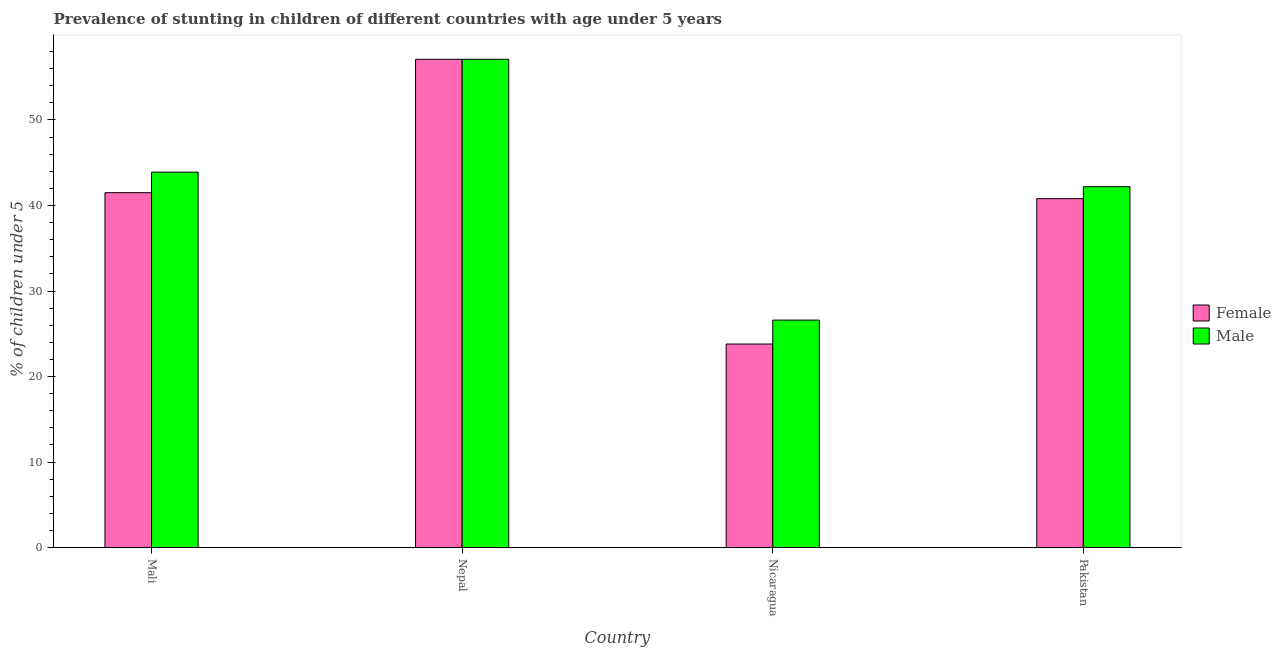Are the number of bars on each tick of the X-axis equal?
Your response must be concise. Yes. How many bars are there on the 1st tick from the left?
Offer a terse response. 2. How many bars are there on the 2nd tick from the right?
Your answer should be compact. 2. What is the label of the 4th group of bars from the left?
Keep it short and to the point. Pakistan. In how many cases, is the number of bars for a given country not equal to the number of legend labels?
Offer a terse response. 0. What is the percentage of stunted female children in Nepal?
Keep it short and to the point. 57.1. Across all countries, what is the maximum percentage of stunted female children?
Offer a terse response. 57.1. Across all countries, what is the minimum percentage of stunted female children?
Your response must be concise. 23.8. In which country was the percentage of stunted female children maximum?
Keep it short and to the point. Nepal. In which country was the percentage of stunted female children minimum?
Offer a very short reply. Nicaragua. What is the total percentage of stunted male children in the graph?
Make the answer very short. 169.8. What is the difference between the percentage of stunted male children in Mali and that in Nepal?
Keep it short and to the point. -13.2. What is the difference between the percentage of stunted female children in Mali and the percentage of stunted male children in Nepal?
Your answer should be very brief. -15.6. What is the average percentage of stunted female children per country?
Keep it short and to the point. 40.8. What is the difference between the percentage of stunted female children and percentage of stunted male children in Pakistan?
Provide a succinct answer. -1.4. In how many countries, is the percentage of stunted female children greater than 8 %?
Offer a terse response. 4. What is the ratio of the percentage of stunted male children in Nepal to that in Nicaragua?
Provide a succinct answer. 2.15. Is the percentage of stunted female children in Nepal less than that in Pakistan?
Your answer should be very brief. No. What is the difference between the highest and the second highest percentage of stunted male children?
Your response must be concise. 13.2. What is the difference between the highest and the lowest percentage of stunted male children?
Offer a terse response. 30.5. Is the sum of the percentage of stunted female children in Mali and Pakistan greater than the maximum percentage of stunted male children across all countries?
Give a very brief answer. Yes. How many bars are there?
Your answer should be compact. 8. Are all the bars in the graph horizontal?
Make the answer very short. No. How many countries are there in the graph?
Your answer should be compact. 4. What is the difference between two consecutive major ticks on the Y-axis?
Ensure brevity in your answer.  10. Are the values on the major ticks of Y-axis written in scientific E-notation?
Ensure brevity in your answer.  No. Does the graph contain any zero values?
Offer a very short reply. No. How are the legend labels stacked?
Offer a very short reply. Vertical. What is the title of the graph?
Provide a succinct answer. Prevalence of stunting in children of different countries with age under 5 years. What is the label or title of the Y-axis?
Provide a succinct answer.  % of children under 5. What is the  % of children under 5 of Female in Mali?
Provide a short and direct response. 41.5. What is the  % of children under 5 of Male in Mali?
Ensure brevity in your answer.  43.9. What is the  % of children under 5 in Female in Nepal?
Ensure brevity in your answer.  57.1. What is the  % of children under 5 of Male in Nepal?
Your answer should be compact. 57.1. What is the  % of children under 5 of Female in Nicaragua?
Give a very brief answer. 23.8. What is the  % of children under 5 in Male in Nicaragua?
Your response must be concise. 26.6. What is the  % of children under 5 in Female in Pakistan?
Your answer should be compact. 40.8. What is the  % of children under 5 of Male in Pakistan?
Keep it short and to the point. 42.2. Across all countries, what is the maximum  % of children under 5 of Female?
Ensure brevity in your answer.  57.1. Across all countries, what is the maximum  % of children under 5 of Male?
Ensure brevity in your answer.  57.1. Across all countries, what is the minimum  % of children under 5 in Female?
Provide a succinct answer. 23.8. Across all countries, what is the minimum  % of children under 5 of Male?
Make the answer very short. 26.6. What is the total  % of children under 5 of Female in the graph?
Give a very brief answer. 163.2. What is the total  % of children under 5 in Male in the graph?
Offer a terse response. 169.8. What is the difference between the  % of children under 5 in Female in Mali and that in Nepal?
Your answer should be compact. -15.6. What is the difference between the  % of children under 5 of Male in Mali and that in Nepal?
Make the answer very short. -13.2. What is the difference between the  % of children under 5 in Female in Mali and that in Nicaragua?
Keep it short and to the point. 17.7. What is the difference between the  % of children under 5 of Male in Mali and that in Nicaragua?
Offer a very short reply. 17.3. What is the difference between the  % of children under 5 in Female in Mali and that in Pakistan?
Offer a very short reply. 0.7. What is the difference between the  % of children under 5 in Female in Nepal and that in Nicaragua?
Provide a succinct answer. 33.3. What is the difference between the  % of children under 5 of Male in Nepal and that in Nicaragua?
Provide a succinct answer. 30.5. What is the difference between the  % of children under 5 of Male in Nicaragua and that in Pakistan?
Your response must be concise. -15.6. What is the difference between the  % of children under 5 of Female in Mali and the  % of children under 5 of Male in Nepal?
Keep it short and to the point. -15.6. What is the difference between the  % of children under 5 in Female in Mali and the  % of children under 5 in Male in Nicaragua?
Your answer should be very brief. 14.9. What is the difference between the  % of children under 5 of Female in Nepal and the  % of children under 5 of Male in Nicaragua?
Your answer should be very brief. 30.5. What is the difference between the  % of children under 5 in Female in Nicaragua and the  % of children under 5 in Male in Pakistan?
Make the answer very short. -18.4. What is the average  % of children under 5 in Female per country?
Give a very brief answer. 40.8. What is the average  % of children under 5 in Male per country?
Provide a succinct answer. 42.45. What is the difference between the  % of children under 5 of Female and  % of children under 5 of Male in Nepal?
Provide a succinct answer. 0. What is the difference between the  % of children under 5 in Female and  % of children under 5 in Male in Nicaragua?
Keep it short and to the point. -2.8. What is the ratio of the  % of children under 5 of Female in Mali to that in Nepal?
Offer a very short reply. 0.73. What is the ratio of the  % of children under 5 of Male in Mali to that in Nepal?
Your answer should be compact. 0.77. What is the ratio of the  % of children under 5 in Female in Mali to that in Nicaragua?
Your response must be concise. 1.74. What is the ratio of the  % of children under 5 of Male in Mali to that in Nicaragua?
Your response must be concise. 1.65. What is the ratio of the  % of children under 5 of Female in Mali to that in Pakistan?
Ensure brevity in your answer.  1.02. What is the ratio of the  % of children under 5 of Male in Mali to that in Pakistan?
Keep it short and to the point. 1.04. What is the ratio of the  % of children under 5 in Female in Nepal to that in Nicaragua?
Provide a short and direct response. 2.4. What is the ratio of the  % of children under 5 of Male in Nepal to that in Nicaragua?
Keep it short and to the point. 2.15. What is the ratio of the  % of children under 5 in Female in Nepal to that in Pakistan?
Keep it short and to the point. 1.4. What is the ratio of the  % of children under 5 in Male in Nepal to that in Pakistan?
Give a very brief answer. 1.35. What is the ratio of the  % of children under 5 in Female in Nicaragua to that in Pakistan?
Your response must be concise. 0.58. What is the ratio of the  % of children under 5 in Male in Nicaragua to that in Pakistan?
Make the answer very short. 0.63. What is the difference between the highest and the second highest  % of children under 5 of Female?
Provide a short and direct response. 15.6. What is the difference between the highest and the second highest  % of children under 5 in Male?
Keep it short and to the point. 13.2. What is the difference between the highest and the lowest  % of children under 5 in Female?
Make the answer very short. 33.3. What is the difference between the highest and the lowest  % of children under 5 in Male?
Your answer should be very brief. 30.5. 